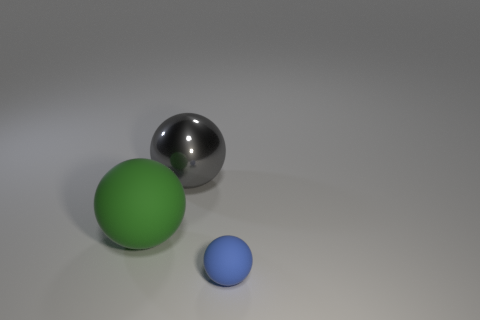How many objects are either objects on the left side of the tiny object or gray metal objects?
Keep it short and to the point. 2. What is the size of the rubber thing that is on the right side of the big shiny thing?
Offer a very short reply. Small. What is the tiny sphere made of?
Ensure brevity in your answer.  Rubber. There is a rubber object that is left of the matte thing to the right of the large metal ball; what shape is it?
Provide a short and direct response. Sphere. There is a green matte object; are there any green matte balls behind it?
Your answer should be compact. No. The big shiny thing is what color?
Your response must be concise. Gray. Does the small matte sphere have the same color as the rubber thing that is on the left side of the blue matte ball?
Provide a short and direct response. No. Is there a gray cylinder that has the same size as the shiny object?
Ensure brevity in your answer.  No. What is the material of the ball that is to the right of the large metal sphere?
Provide a short and direct response. Rubber. Are there the same number of large rubber objects to the left of the tiny object and big green rubber things that are behind the green ball?
Provide a succinct answer. No. 